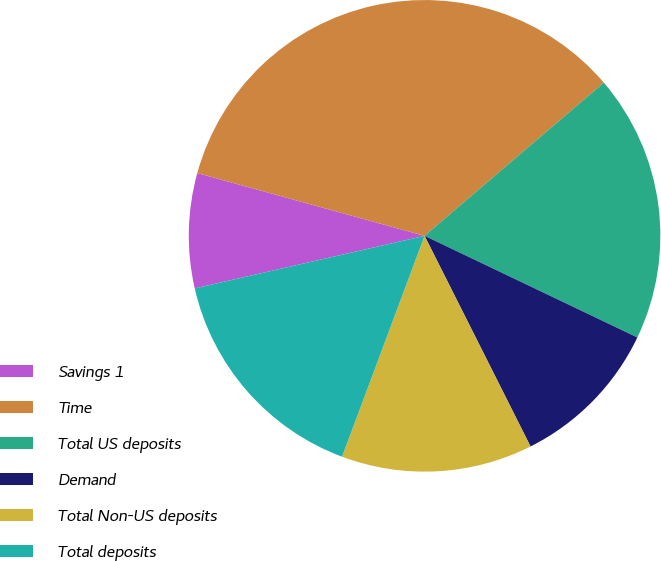Convert chart. <chart><loc_0><loc_0><loc_500><loc_500><pie_chart><fcel>Savings 1<fcel>Time<fcel>Total US deposits<fcel>Demand<fcel>Total Non-US deposits<fcel>Total deposits<nl><fcel>7.87%<fcel>34.46%<fcel>18.35%<fcel>10.49%<fcel>13.11%<fcel>15.73%<nl></chart> 